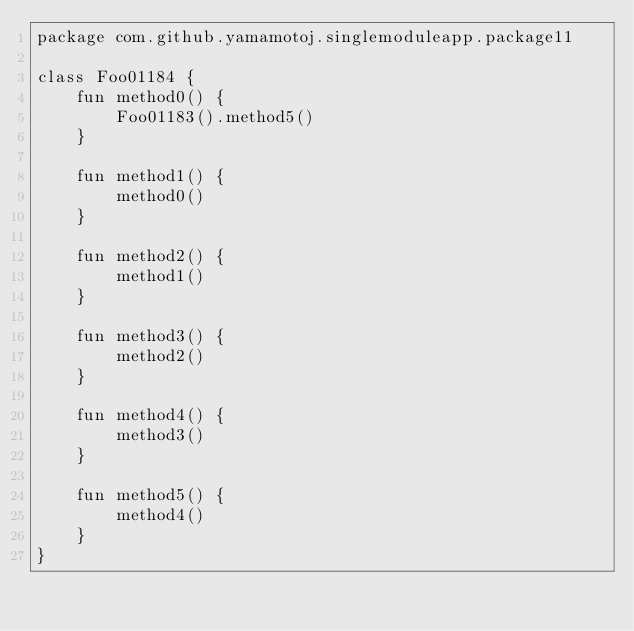<code> <loc_0><loc_0><loc_500><loc_500><_Kotlin_>package com.github.yamamotoj.singlemoduleapp.package11

class Foo01184 {
    fun method0() {
        Foo01183().method5()
    }

    fun method1() {
        method0()
    }

    fun method2() {
        method1()
    }

    fun method3() {
        method2()
    }

    fun method4() {
        method3()
    }

    fun method5() {
        method4()
    }
}
</code> 